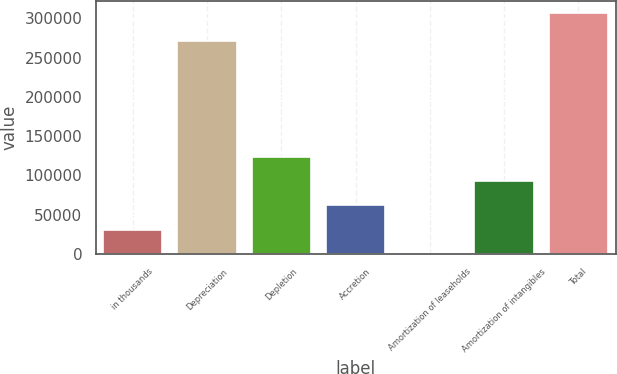Convert chart to OTSL. <chart><loc_0><loc_0><loc_500><loc_500><bar_chart><fcel>in thousands<fcel>Depreciation<fcel>Depletion<fcel>Accretion<fcel>Amortization of leaseholds<fcel>Amortization of intangibles<fcel>Total<nl><fcel>31145.5<fcel>271180<fcel>123133<fcel>61808<fcel>483<fcel>92470.5<fcel>307108<nl></chart> 